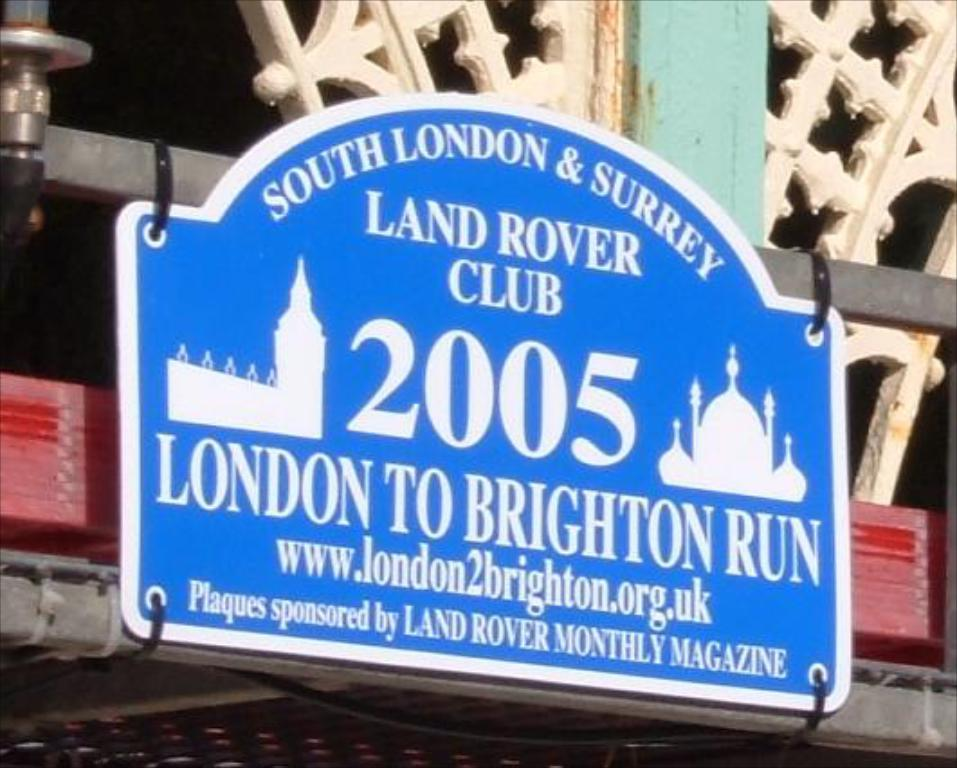<image>
Present a compact description of the photo's key features. A blue plaque that is sponsored by Land Rover monthly magazine. 